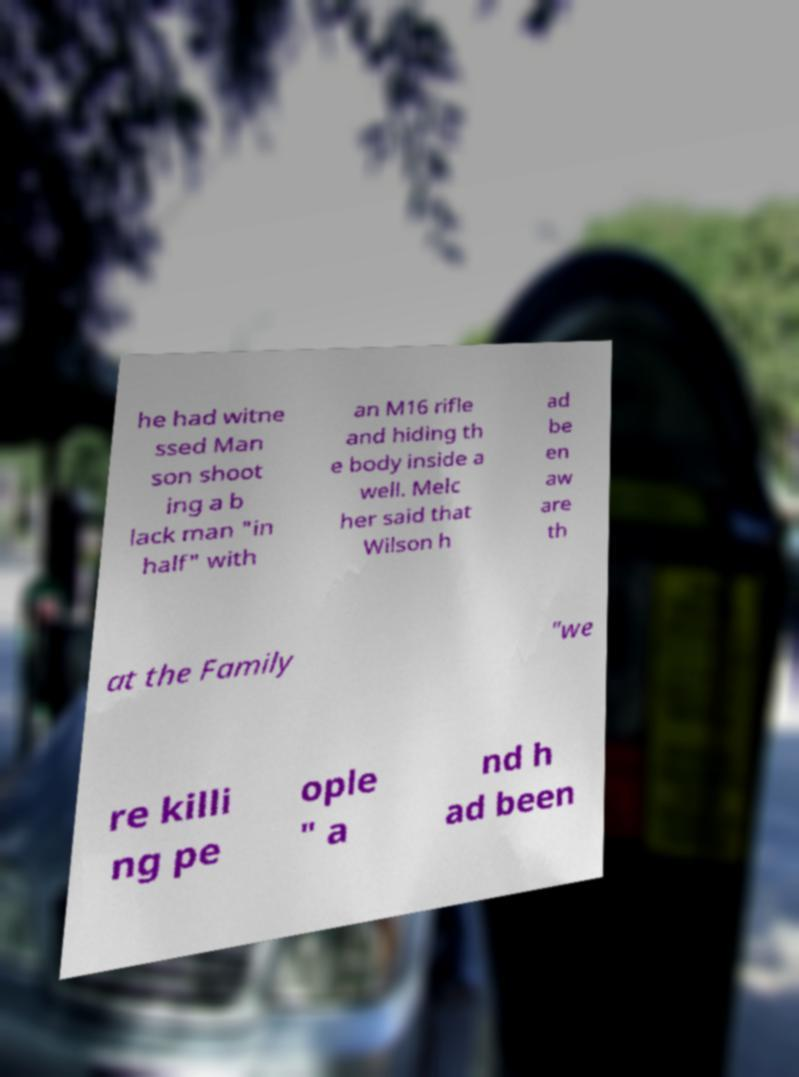What messages or text are displayed in this image? I need them in a readable, typed format. he had witne ssed Man son shoot ing a b lack man "in half" with an M16 rifle and hiding th e body inside a well. Melc her said that Wilson h ad be en aw are th at the Family "we re killi ng pe ople " a nd h ad been 